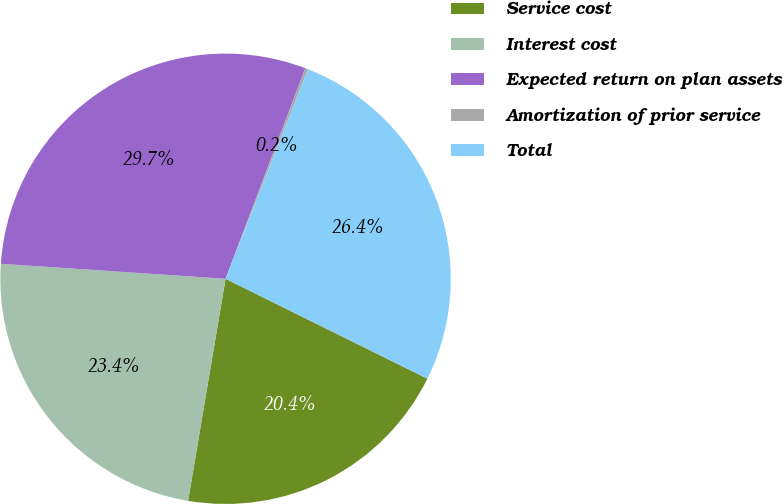<chart> <loc_0><loc_0><loc_500><loc_500><pie_chart><fcel>Service cost<fcel>Interest cost<fcel>Expected return on plan assets<fcel>Amortization of prior service<fcel>Total<nl><fcel>20.35%<fcel>23.4%<fcel>29.7%<fcel>0.2%<fcel>26.35%<nl></chart> 